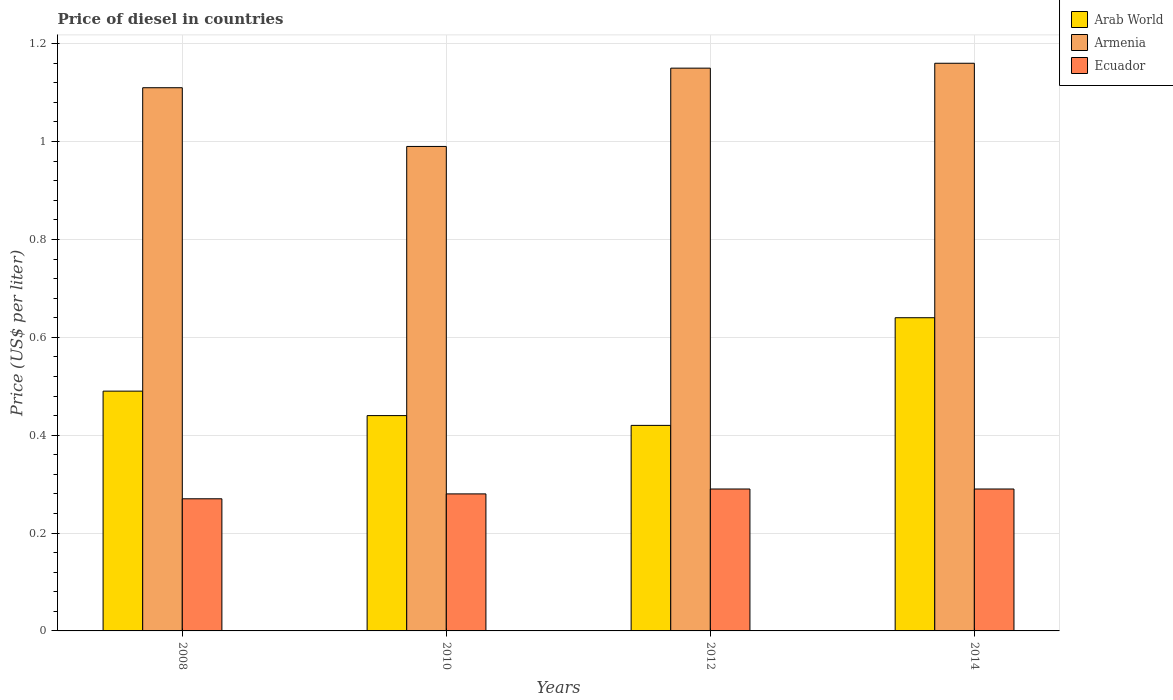How many groups of bars are there?
Your response must be concise. 4. How many bars are there on the 3rd tick from the left?
Ensure brevity in your answer.  3. What is the label of the 1st group of bars from the left?
Provide a short and direct response. 2008. In how many cases, is the number of bars for a given year not equal to the number of legend labels?
Your answer should be compact. 0. What is the price of diesel in Arab World in 2008?
Offer a very short reply. 0.49. Across all years, what is the maximum price of diesel in Ecuador?
Your response must be concise. 0.29. Across all years, what is the minimum price of diesel in Ecuador?
Offer a very short reply. 0.27. What is the total price of diesel in Arab World in the graph?
Offer a terse response. 1.99. What is the difference between the price of diesel in Ecuador in 2008 and that in 2012?
Provide a short and direct response. -0.02. What is the difference between the price of diesel in Arab World in 2010 and the price of diesel in Ecuador in 2014?
Your answer should be very brief. 0.15. What is the average price of diesel in Armenia per year?
Ensure brevity in your answer.  1.1. In the year 2012, what is the difference between the price of diesel in Ecuador and price of diesel in Arab World?
Offer a terse response. -0.13. In how many years, is the price of diesel in Armenia greater than 0.08 US$?
Provide a succinct answer. 4. What is the ratio of the price of diesel in Armenia in 2008 to that in 2010?
Provide a succinct answer. 1.12. Is the difference between the price of diesel in Ecuador in 2012 and 2014 greater than the difference between the price of diesel in Arab World in 2012 and 2014?
Provide a succinct answer. Yes. What is the difference between the highest and the second highest price of diesel in Arab World?
Give a very brief answer. 0.15. What is the difference between the highest and the lowest price of diesel in Ecuador?
Your answer should be compact. 0.02. In how many years, is the price of diesel in Arab World greater than the average price of diesel in Arab World taken over all years?
Provide a short and direct response. 1. What does the 3rd bar from the left in 2008 represents?
Offer a very short reply. Ecuador. What does the 1st bar from the right in 2012 represents?
Provide a succinct answer. Ecuador. How many bars are there?
Offer a very short reply. 12. Are all the bars in the graph horizontal?
Give a very brief answer. No. What is the difference between two consecutive major ticks on the Y-axis?
Your answer should be compact. 0.2. Are the values on the major ticks of Y-axis written in scientific E-notation?
Make the answer very short. No. Does the graph contain grids?
Make the answer very short. Yes. How are the legend labels stacked?
Provide a short and direct response. Vertical. What is the title of the graph?
Your answer should be very brief. Price of diesel in countries. Does "High income: nonOECD" appear as one of the legend labels in the graph?
Make the answer very short. No. What is the label or title of the Y-axis?
Ensure brevity in your answer.  Price (US$ per liter). What is the Price (US$ per liter) in Arab World in 2008?
Offer a terse response. 0.49. What is the Price (US$ per liter) of Armenia in 2008?
Make the answer very short. 1.11. What is the Price (US$ per liter) in Ecuador in 2008?
Offer a terse response. 0.27. What is the Price (US$ per liter) in Arab World in 2010?
Ensure brevity in your answer.  0.44. What is the Price (US$ per liter) in Armenia in 2010?
Offer a terse response. 0.99. What is the Price (US$ per liter) in Ecuador in 2010?
Offer a terse response. 0.28. What is the Price (US$ per liter) in Arab World in 2012?
Keep it short and to the point. 0.42. What is the Price (US$ per liter) in Armenia in 2012?
Your answer should be compact. 1.15. What is the Price (US$ per liter) of Ecuador in 2012?
Offer a terse response. 0.29. What is the Price (US$ per liter) of Arab World in 2014?
Provide a short and direct response. 0.64. What is the Price (US$ per liter) of Armenia in 2014?
Provide a short and direct response. 1.16. What is the Price (US$ per liter) in Ecuador in 2014?
Make the answer very short. 0.29. Across all years, what is the maximum Price (US$ per liter) in Arab World?
Ensure brevity in your answer.  0.64. Across all years, what is the maximum Price (US$ per liter) in Armenia?
Your answer should be very brief. 1.16. Across all years, what is the maximum Price (US$ per liter) of Ecuador?
Provide a short and direct response. 0.29. Across all years, what is the minimum Price (US$ per liter) in Arab World?
Offer a terse response. 0.42. Across all years, what is the minimum Price (US$ per liter) in Armenia?
Provide a succinct answer. 0.99. Across all years, what is the minimum Price (US$ per liter) in Ecuador?
Keep it short and to the point. 0.27. What is the total Price (US$ per liter) in Arab World in the graph?
Offer a terse response. 1.99. What is the total Price (US$ per liter) of Armenia in the graph?
Your response must be concise. 4.41. What is the total Price (US$ per liter) of Ecuador in the graph?
Ensure brevity in your answer.  1.13. What is the difference between the Price (US$ per liter) in Arab World in 2008 and that in 2010?
Ensure brevity in your answer.  0.05. What is the difference between the Price (US$ per liter) of Armenia in 2008 and that in 2010?
Give a very brief answer. 0.12. What is the difference between the Price (US$ per liter) in Ecuador in 2008 and that in 2010?
Make the answer very short. -0.01. What is the difference between the Price (US$ per liter) in Arab World in 2008 and that in 2012?
Provide a short and direct response. 0.07. What is the difference between the Price (US$ per liter) of Armenia in 2008 and that in 2012?
Your answer should be compact. -0.04. What is the difference between the Price (US$ per liter) of Ecuador in 2008 and that in 2012?
Your response must be concise. -0.02. What is the difference between the Price (US$ per liter) of Armenia in 2008 and that in 2014?
Give a very brief answer. -0.05. What is the difference between the Price (US$ per liter) in Ecuador in 2008 and that in 2014?
Keep it short and to the point. -0.02. What is the difference between the Price (US$ per liter) of Arab World in 2010 and that in 2012?
Your response must be concise. 0.02. What is the difference between the Price (US$ per liter) in Armenia in 2010 and that in 2012?
Give a very brief answer. -0.16. What is the difference between the Price (US$ per liter) of Ecuador in 2010 and that in 2012?
Keep it short and to the point. -0.01. What is the difference between the Price (US$ per liter) of Armenia in 2010 and that in 2014?
Offer a very short reply. -0.17. What is the difference between the Price (US$ per liter) in Ecuador in 2010 and that in 2014?
Make the answer very short. -0.01. What is the difference between the Price (US$ per liter) in Arab World in 2012 and that in 2014?
Your answer should be very brief. -0.22. What is the difference between the Price (US$ per liter) of Armenia in 2012 and that in 2014?
Make the answer very short. -0.01. What is the difference between the Price (US$ per liter) of Arab World in 2008 and the Price (US$ per liter) of Armenia in 2010?
Your answer should be very brief. -0.5. What is the difference between the Price (US$ per liter) in Arab World in 2008 and the Price (US$ per liter) in Ecuador in 2010?
Give a very brief answer. 0.21. What is the difference between the Price (US$ per liter) in Armenia in 2008 and the Price (US$ per liter) in Ecuador in 2010?
Your answer should be very brief. 0.83. What is the difference between the Price (US$ per liter) of Arab World in 2008 and the Price (US$ per liter) of Armenia in 2012?
Provide a short and direct response. -0.66. What is the difference between the Price (US$ per liter) of Arab World in 2008 and the Price (US$ per liter) of Ecuador in 2012?
Your answer should be compact. 0.2. What is the difference between the Price (US$ per liter) of Armenia in 2008 and the Price (US$ per liter) of Ecuador in 2012?
Offer a very short reply. 0.82. What is the difference between the Price (US$ per liter) of Arab World in 2008 and the Price (US$ per liter) of Armenia in 2014?
Your answer should be compact. -0.67. What is the difference between the Price (US$ per liter) of Arab World in 2008 and the Price (US$ per liter) of Ecuador in 2014?
Give a very brief answer. 0.2. What is the difference between the Price (US$ per liter) of Armenia in 2008 and the Price (US$ per liter) of Ecuador in 2014?
Provide a short and direct response. 0.82. What is the difference between the Price (US$ per liter) in Arab World in 2010 and the Price (US$ per liter) in Armenia in 2012?
Your answer should be very brief. -0.71. What is the difference between the Price (US$ per liter) in Arab World in 2010 and the Price (US$ per liter) in Ecuador in 2012?
Offer a very short reply. 0.15. What is the difference between the Price (US$ per liter) in Arab World in 2010 and the Price (US$ per liter) in Armenia in 2014?
Keep it short and to the point. -0.72. What is the difference between the Price (US$ per liter) of Arab World in 2010 and the Price (US$ per liter) of Ecuador in 2014?
Ensure brevity in your answer.  0.15. What is the difference between the Price (US$ per liter) of Armenia in 2010 and the Price (US$ per liter) of Ecuador in 2014?
Your response must be concise. 0.7. What is the difference between the Price (US$ per liter) of Arab World in 2012 and the Price (US$ per liter) of Armenia in 2014?
Provide a succinct answer. -0.74. What is the difference between the Price (US$ per liter) in Arab World in 2012 and the Price (US$ per liter) in Ecuador in 2014?
Offer a very short reply. 0.13. What is the difference between the Price (US$ per liter) of Armenia in 2012 and the Price (US$ per liter) of Ecuador in 2014?
Provide a short and direct response. 0.86. What is the average Price (US$ per liter) of Arab World per year?
Provide a succinct answer. 0.5. What is the average Price (US$ per liter) in Armenia per year?
Your response must be concise. 1.1. What is the average Price (US$ per liter) in Ecuador per year?
Give a very brief answer. 0.28. In the year 2008, what is the difference between the Price (US$ per liter) of Arab World and Price (US$ per liter) of Armenia?
Ensure brevity in your answer.  -0.62. In the year 2008, what is the difference between the Price (US$ per liter) of Arab World and Price (US$ per liter) of Ecuador?
Offer a very short reply. 0.22. In the year 2008, what is the difference between the Price (US$ per liter) of Armenia and Price (US$ per liter) of Ecuador?
Your answer should be compact. 0.84. In the year 2010, what is the difference between the Price (US$ per liter) of Arab World and Price (US$ per liter) of Armenia?
Your answer should be compact. -0.55. In the year 2010, what is the difference between the Price (US$ per liter) in Arab World and Price (US$ per liter) in Ecuador?
Offer a very short reply. 0.16. In the year 2010, what is the difference between the Price (US$ per liter) of Armenia and Price (US$ per liter) of Ecuador?
Keep it short and to the point. 0.71. In the year 2012, what is the difference between the Price (US$ per liter) of Arab World and Price (US$ per liter) of Armenia?
Offer a very short reply. -0.73. In the year 2012, what is the difference between the Price (US$ per liter) of Arab World and Price (US$ per liter) of Ecuador?
Your response must be concise. 0.13. In the year 2012, what is the difference between the Price (US$ per liter) in Armenia and Price (US$ per liter) in Ecuador?
Your response must be concise. 0.86. In the year 2014, what is the difference between the Price (US$ per liter) in Arab World and Price (US$ per liter) in Armenia?
Provide a short and direct response. -0.52. In the year 2014, what is the difference between the Price (US$ per liter) in Armenia and Price (US$ per liter) in Ecuador?
Offer a very short reply. 0.87. What is the ratio of the Price (US$ per liter) of Arab World in 2008 to that in 2010?
Make the answer very short. 1.11. What is the ratio of the Price (US$ per liter) of Armenia in 2008 to that in 2010?
Offer a very short reply. 1.12. What is the ratio of the Price (US$ per liter) of Armenia in 2008 to that in 2012?
Offer a terse response. 0.97. What is the ratio of the Price (US$ per liter) in Ecuador in 2008 to that in 2012?
Keep it short and to the point. 0.93. What is the ratio of the Price (US$ per liter) in Arab World in 2008 to that in 2014?
Your response must be concise. 0.77. What is the ratio of the Price (US$ per liter) of Armenia in 2008 to that in 2014?
Offer a very short reply. 0.96. What is the ratio of the Price (US$ per liter) in Arab World in 2010 to that in 2012?
Your response must be concise. 1.05. What is the ratio of the Price (US$ per liter) in Armenia in 2010 to that in 2012?
Make the answer very short. 0.86. What is the ratio of the Price (US$ per liter) in Ecuador in 2010 to that in 2012?
Your answer should be very brief. 0.97. What is the ratio of the Price (US$ per liter) of Arab World in 2010 to that in 2014?
Your answer should be very brief. 0.69. What is the ratio of the Price (US$ per liter) in Armenia in 2010 to that in 2014?
Make the answer very short. 0.85. What is the ratio of the Price (US$ per liter) in Ecuador in 2010 to that in 2014?
Give a very brief answer. 0.97. What is the ratio of the Price (US$ per liter) in Arab World in 2012 to that in 2014?
Your answer should be compact. 0.66. What is the ratio of the Price (US$ per liter) in Armenia in 2012 to that in 2014?
Make the answer very short. 0.99. What is the ratio of the Price (US$ per liter) of Ecuador in 2012 to that in 2014?
Give a very brief answer. 1. What is the difference between the highest and the second highest Price (US$ per liter) in Arab World?
Provide a succinct answer. 0.15. What is the difference between the highest and the lowest Price (US$ per liter) in Arab World?
Offer a very short reply. 0.22. What is the difference between the highest and the lowest Price (US$ per liter) in Armenia?
Keep it short and to the point. 0.17. 